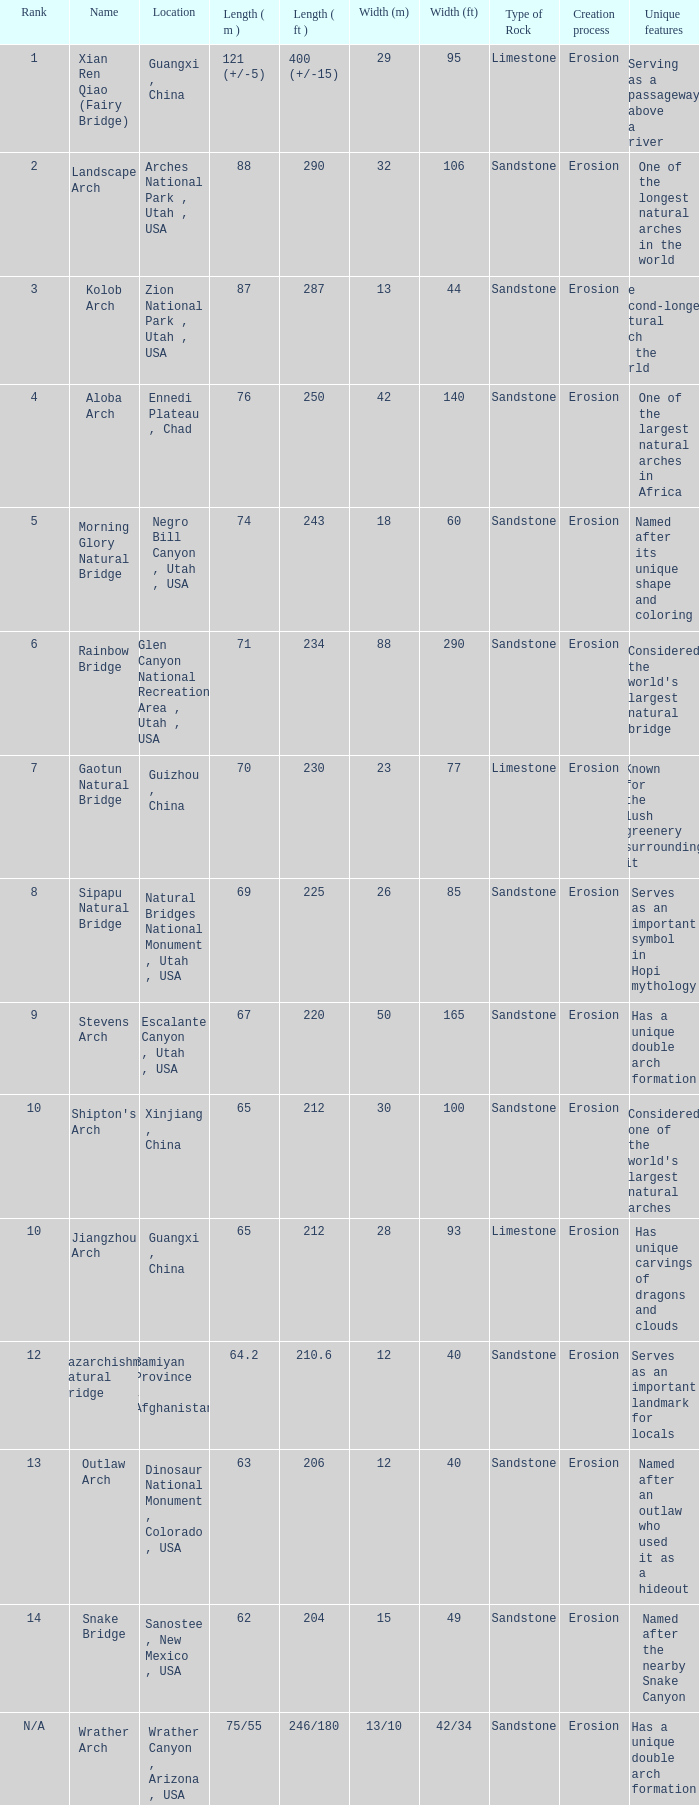Where is the longest arch with a length in meters of 63? Dinosaur National Monument , Colorado , USA. 